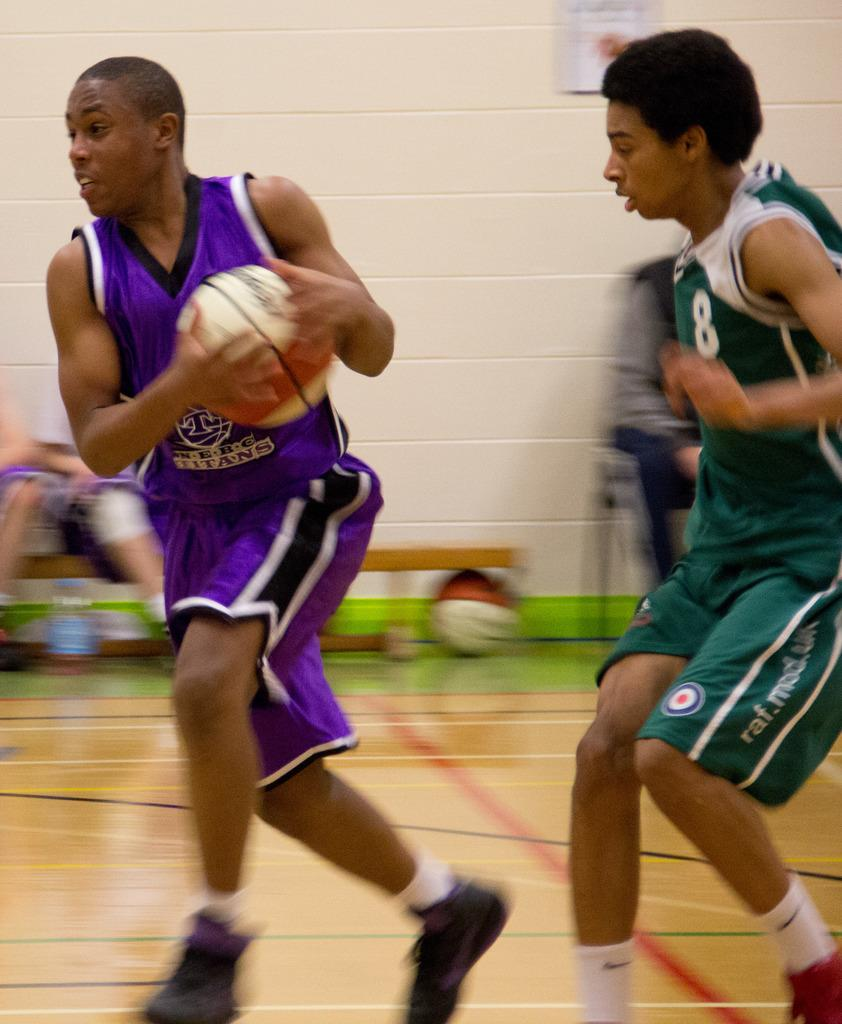<image>
Provide a brief description of the given image. two basketball players on the court, the player in green sponsored by raf.mod.uk 